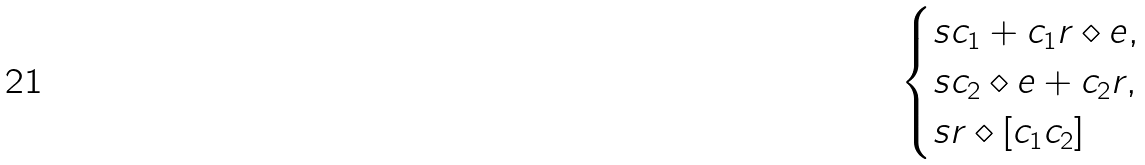Convert formula to latex. <formula><loc_0><loc_0><loc_500><loc_500>\begin{cases} s c _ { 1 } + c _ { 1 } r \diamond e , \\ s c _ { 2 } \diamond e + c _ { 2 } r , \\ s r \diamond [ c _ { 1 } c _ { 2 } ] \end{cases}</formula> 